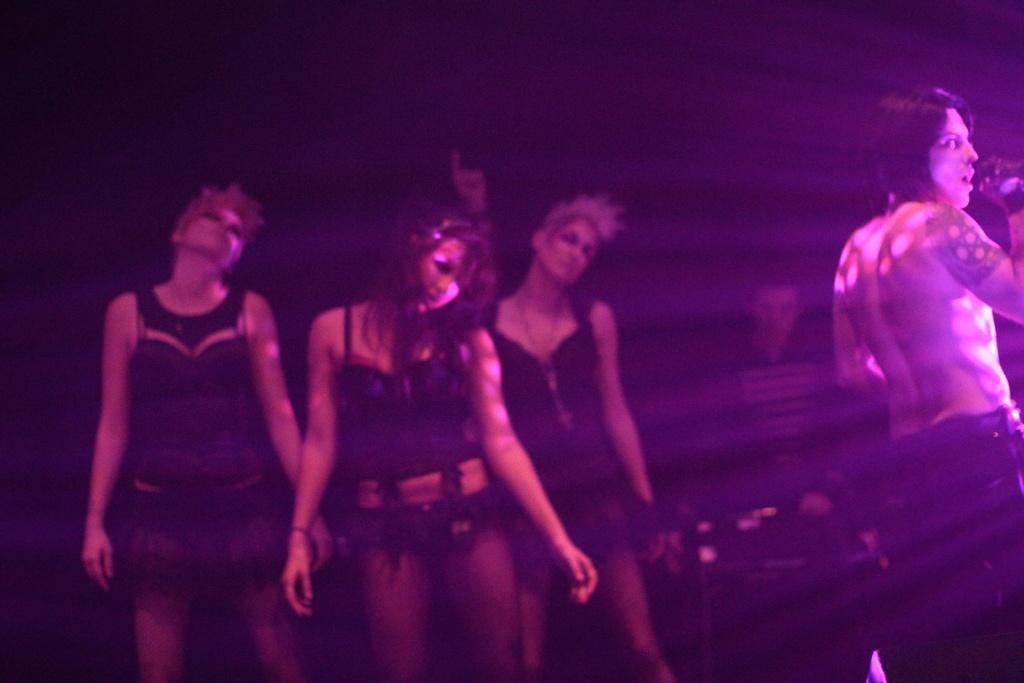In one or two sentences, can you explain what this image depicts? This image is taken in a concert. In this image the background is dark and there is a person. In the middle of the image three women are standing and performing. On the right side of the image a man is standing and singing. 